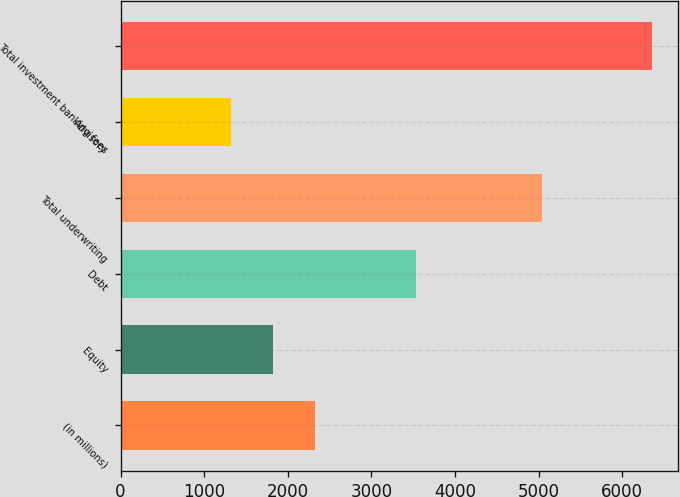Convert chart. <chart><loc_0><loc_0><loc_500><loc_500><bar_chart><fcel>(in millions)<fcel>Equity<fcel>Debt<fcel>Total underwriting<fcel>Advisory<fcel>Total investment banking fees<nl><fcel>2325.2<fcel>1821.6<fcel>3537<fcel>5036<fcel>1318<fcel>6354<nl></chart> 